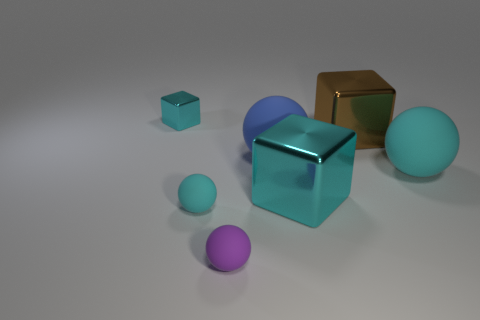Subtract all large cubes. How many cubes are left? 1 Subtract all red cubes. How many cyan balls are left? 2 Subtract all purple balls. How many balls are left? 3 Add 2 blue rubber balls. How many objects exist? 9 Subtract all gray balls. Subtract all green cylinders. How many balls are left? 4 Subtract all blocks. How many objects are left? 4 Subtract all large cyan shiny cubes. Subtract all cyan matte things. How many objects are left? 4 Add 7 tiny cyan rubber balls. How many tiny cyan rubber balls are left? 8 Add 3 big things. How many big things exist? 7 Subtract 0 gray cylinders. How many objects are left? 7 